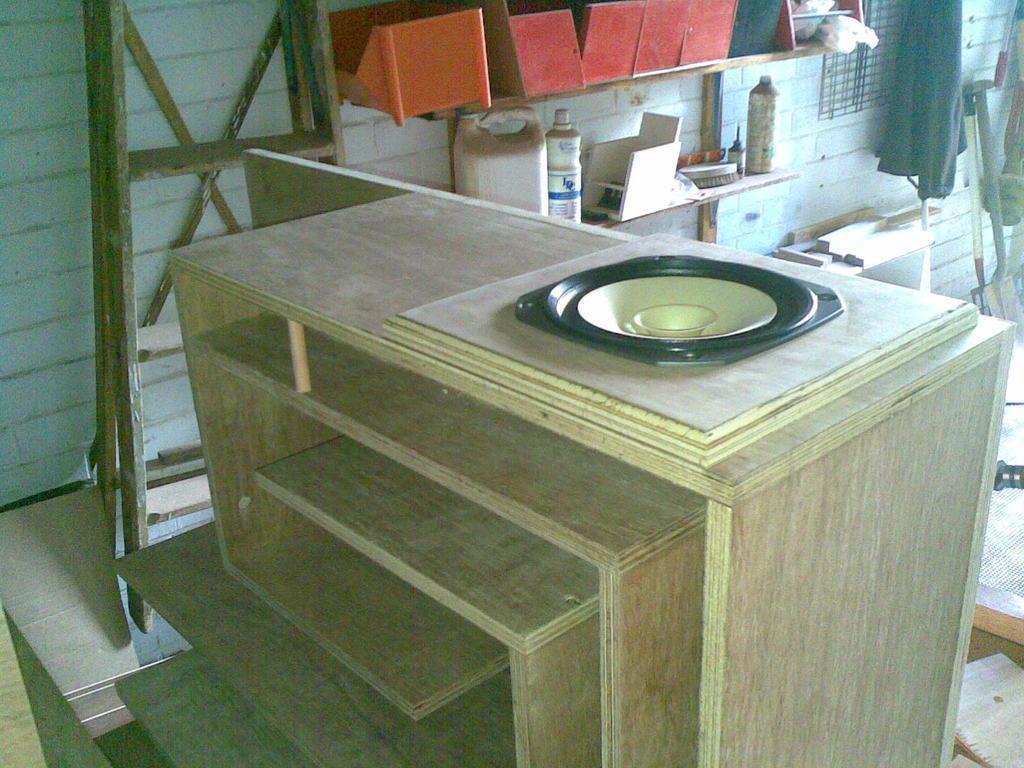Could you give a brief overview of what you see in this image? In this picture there is a wooden rack in the center of the image and there are boxes, bottles and a ladder in the background area of the image, there is a spade in the image. 